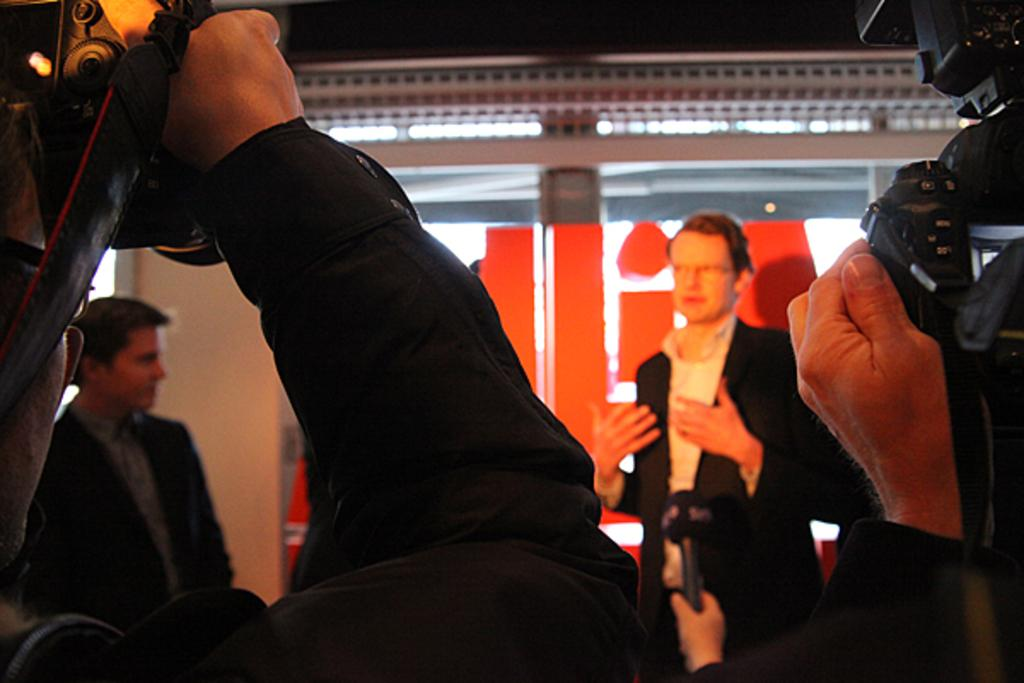Who or what can be seen in the image? There are people in the image. What else is present in the image besides people? There are lights and objects in the image. What is one person doing in the image? One person is holding a microphone. What are two other people doing in the image? Two people are holding cameras. What type of line or border can be seen in the wilderness in the image? There is no wilderness or line/border present in the image. 